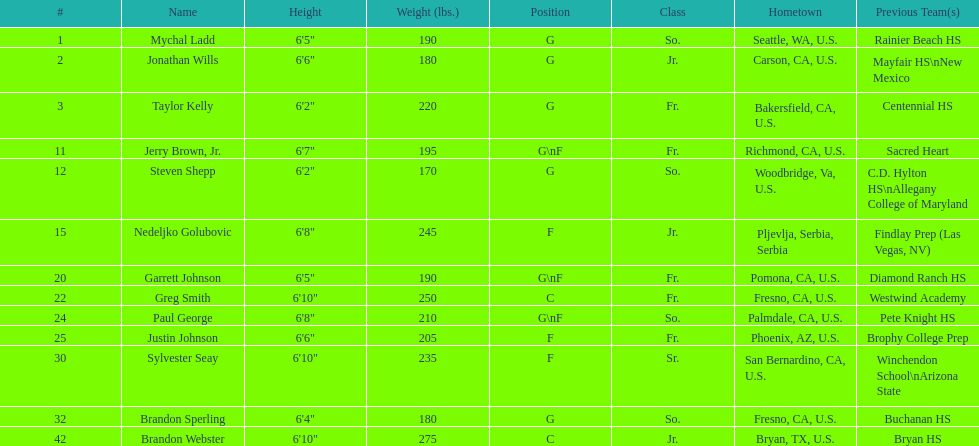Which athlete is taller, paul george or greg smith? Greg Smith. 